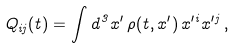<formula> <loc_0><loc_0><loc_500><loc_500>Q _ { i j } ( t ) = \int d ^ { 3 } x ^ { \prime } \, \rho ( t , { x } ^ { \prime } ) \, x ^ { \prime i } x ^ { \prime j } \, ,</formula> 